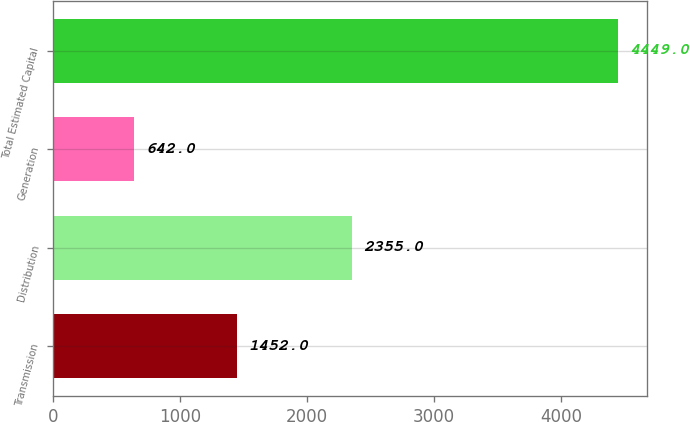Convert chart. <chart><loc_0><loc_0><loc_500><loc_500><bar_chart><fcel>Transmission<fcel>Distribution<fcel>Generation<fcel>Total Estimated Capital<nl><fcel>1452<fcel>2355<fcel>642<fcel>4449<nl></chart> 